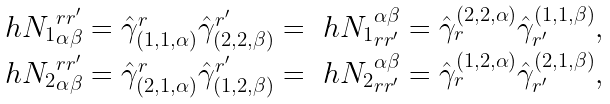Convert formula to latex. <formula><loc_0><loc_0><loc_500><loc_500>\begin{array} { l } { \ h N _ { 1 } } ^ { r r ^ { \prime } } _ { \alpha \beta } = { \hat { \gamma } } ^ { r } _ { ( 1 , 1 , \alpha ) } { \hat { \gamma } } ^ { r ^ { \prime } } _ { ( 2 , 2 , \beta ) } = { \ h N _ { 1 } } _ { r r ^ { \prime } } ^ { \alpha \beta } = { \hat { \gamma } } _ { r } ^ { ( 2 , 2 , \alpha ) } { \hat { \gamma } } _ { r ^ { \prime } } ^ { ( 1 , 1 , \beta ) } , \\ { \ h N _ { 2 } } ^ { r r ^ { \prime } } _ { \alpha \beta } = { \hat { \gamma } } ^ { r } _ { ( 2 , 1 , \alpha ) } { \hat { \gamma } } ^ { r ^ { \prime } } _ { ( 1 , 2 , \beta ) } = { \ h N _ { 2 } } _ { r r ^ { \prime } } ^ { \alpha \beta } = { \hat { \gamma } } _ { r } ^ { ( 1 , 2 , \alpha ) } { \hat { \gamma } } _ { r ^ { \prime } } ^ { ( 2 , 1 , \beta ) } , \end{array}</formula> 